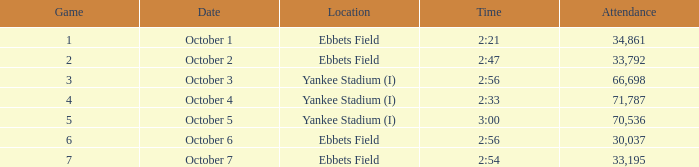What is the smallest attendance for the game of 6? 30037.0. Can you parse all the data within this table? {'header': ['Game', 'Date', 'Location', 'Time', 'Attendance'], 'rows': [['1', 'October 1', 'Ebbets Field', '2:21', '34,861'], ['2', 'October 2', 'Ebbets Field', '2:47', '33,792'], ['3', 'October 3', 'Yankee Stadium (I)', '2:56', '66,698'], ['4', 'October 4', 'Yankee Stadium (I)', '2:33', '71,787'], ['5', 'October 5', 'Yankee Stadium (I)', '3:00', '70,536'], ['6', 'October 6', 'Ebbets Field', '2:56', '30,037'], ['7', 'October 7', 'Ebbets Field', '2:54', '33,195']]} 